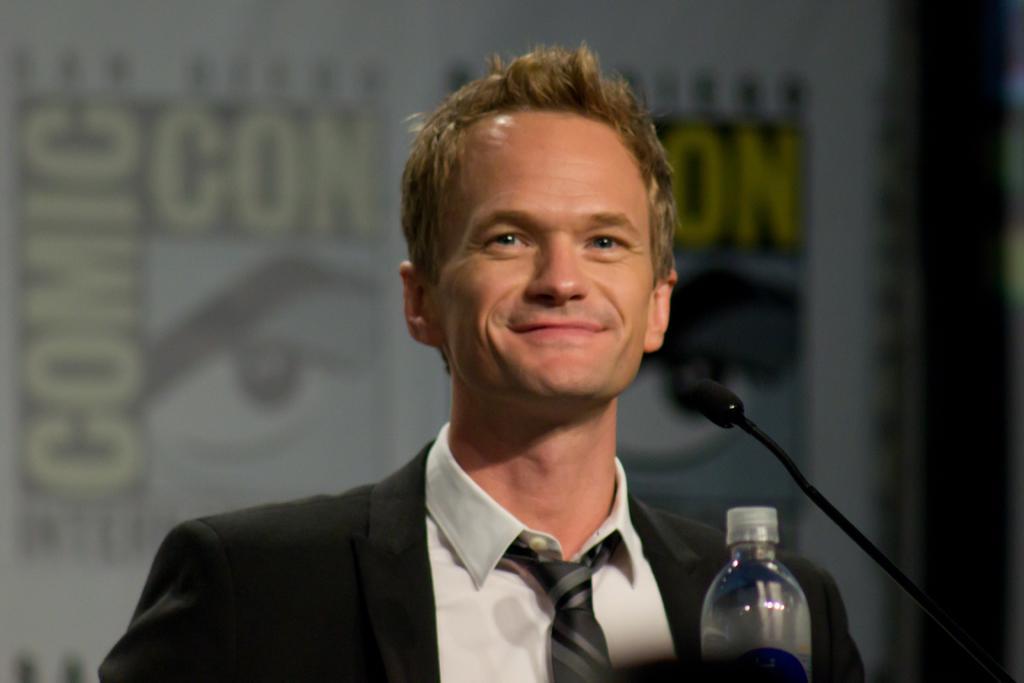Describe this image in one or two sentences. In this picture we can see a man who is in black color suit. He is smiling. And there is a mike and this is the bottle. 